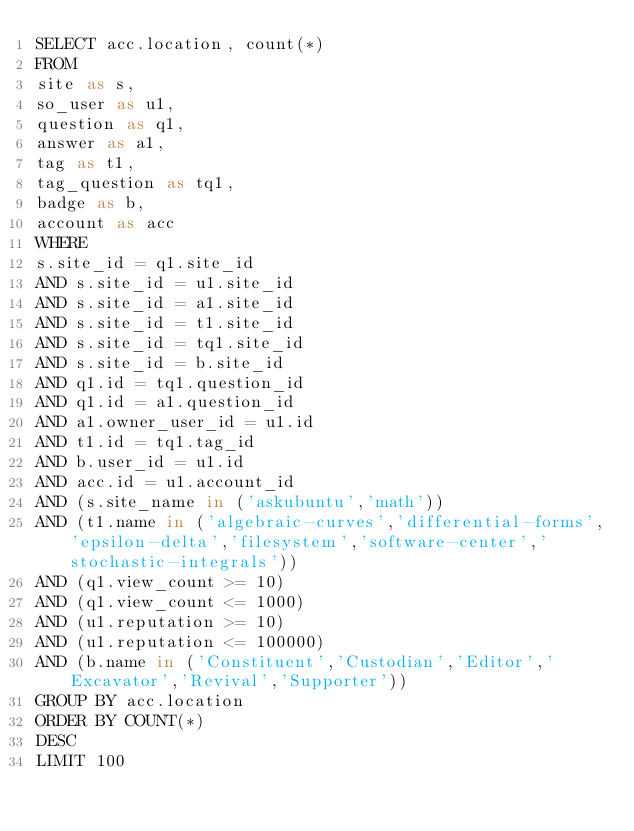Convert code to text. <code><loc_0><loc_0><loc_500><loc_500><_SQL_>SELECT acc.location, count(*)
FROM
site as s,
so_user as u1,
question as q1,
answer as a1,
tag as t1,
tag_question as tq1,
badge as b,
account as acc
WHERE
s.site_id = q1.site_id
AND s.site_id = u1.site_id
AND s.site_id = a1.site_id
AND s.site_id = t1.site_id
AND s.site_id = tq1.site_id
AND s.site_id = b.site_id
AND q1.id = tq1.question_id
AND q1.id = a1.question_id
AND a1.owner_user_id = u1.id
AND t1.id = tq1.tag_id
AND b.user_id = u1.id
AND acc.id = u1.account_id
AND (s.site_name in ('askubuntu','math'))
AND (t1.name in ('algebraic-curves','differential-forms','epsilon-delta','filesystem','software-center','stochastic-integrals'))
AND (q1.view_count >= 10)
AND (q1.view_count <= 1000)
AND (u1.reputation >= 10)
AND (u1.reputation <= 100000)
AND (b.name in ('Constituent','Custodian','Editor','Excavator','Revival','Supporter'))
GROUP BY acc.location
ORDER BY COUNT(*)
DESC
LIMIT 100
</code> 